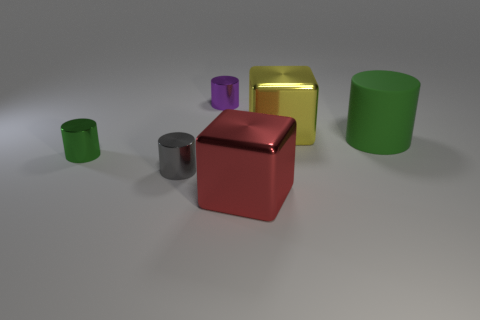There is a green thing on the right side of the red shiny block; what is its material?
Provide a succinct answer. Rubber. There is a big cube behind the green cylinder on the right side of the metallic cylinder on the right side of the gray metal object; what is its color?
Offer a very short reply. Yellow. What color is the other metallic cube that is the same size as the yellow shiny block?
Your answer should be very brief. Red. How many shiny things are small gray cylinders or cylinders?
Your answer should be very brief. 3. The big thing that is made of the same material as the large red cube is what color?
Your response must be concise. Yellow. What material is the cylinder behind the block that is behind the large rubber cylinder made of?
Ensure brevity in your answer.  Metal. How many objects are either cylinders that are behind the large green thing or small metallic things that are to the right of the gray shiny object?
Give a very brief answer. 1. What size is the yellow thing that is behind the large block in front of the green thing that is to the right of the tiny purple thing?
Offer a terse response. Large. Are there the same number of large shiny cubes that are on the left side of the large yellow thing and big gray rubber cylinders?
Your response must be concise. No. Is there anything else that is the same shape as the small purple metal object?
Your response must be concise. Yes. 